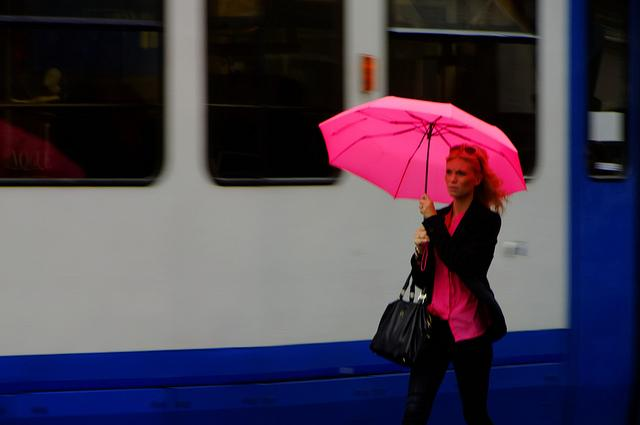Why does the woman use pink umbrella? shade 